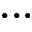<formula> <loc_0><loc_0><loc_500><loc_500>\dots</formula> 